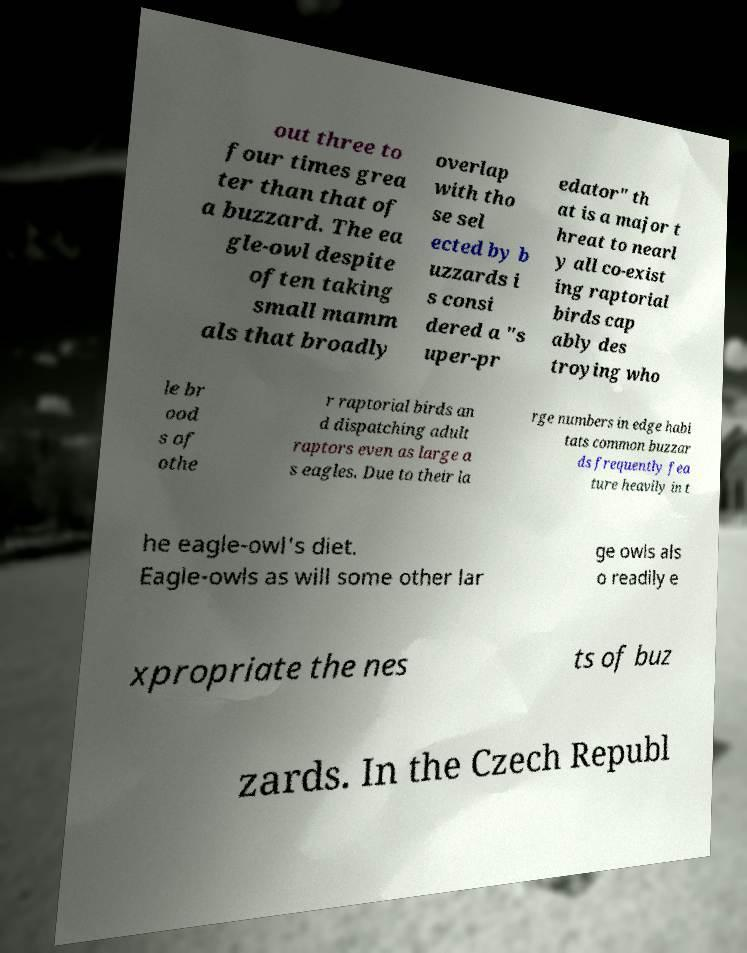Can you accurately transcribe the text from the provided image for me? out three to four times grea ter than that of a buzzard. The ea gle-owl despite often taking small mamm als that broadly overlap with tho se sel ected by b uzzards i s consi dered a "s uper-pr edator" th at is a major t hreat to nearl y all co-exist ing raptorial birds cap ably des troying who le br ood s of othe r raptorial birds an d dispatching adult raptors even as large a s eagles. Due to their la rge numbers in edge habi tats common buzzar ds frequently fea ture heavily in t he eagle-owl's diet. Eagle-owls as will some other lar ge owls als o readily e xpropriate the nes ts of buz zards. In the Czech Republ 